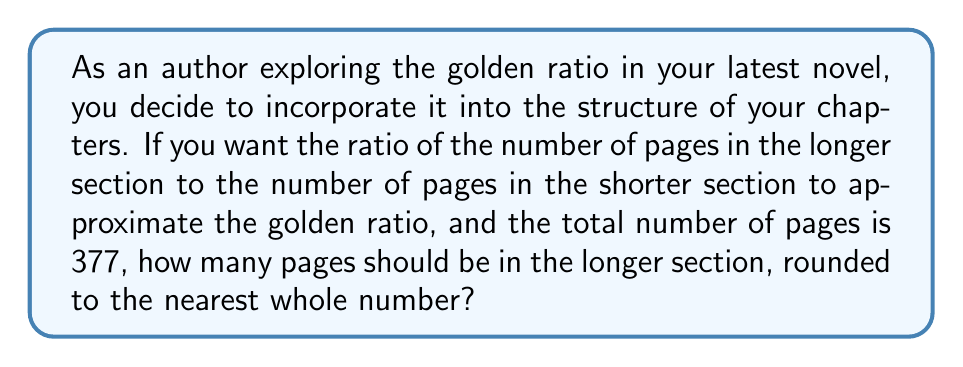Solve this math problem. Let's approach this step-by-step:

1) The golden ratio, often denoted by $\phi$ (phi), is approximately 1.618034...

2) Let $x$ be the number of pages in the shorter section and $y$ be the number of pages in the longer section.

3) We know that $x + y = 377$ (total number of pages)

4) The golden ratio states that $\frac{y}{x} \approx \phi$

5) We can set up the equation:
   $\frac{y}{x} = \phi$

6) Cross-multiplying:
   $y = \phi x$

7) Substituting this into our first equation:
   $x + \phi x = 377$
   $x(1 + \phi) = 377$

8) Solving for $x$:
   $x = \frac{377}{1 + \phi}$

9) We can calculate this:
   $x = \frac{377}{1 + 1.618034...} \approx 144.0$

10) Therefore, $y = 377 - 144 = 233$

11) Rounding to the nearest whole number, we get 233 pages for the longer section.
Answer: 233 pages 